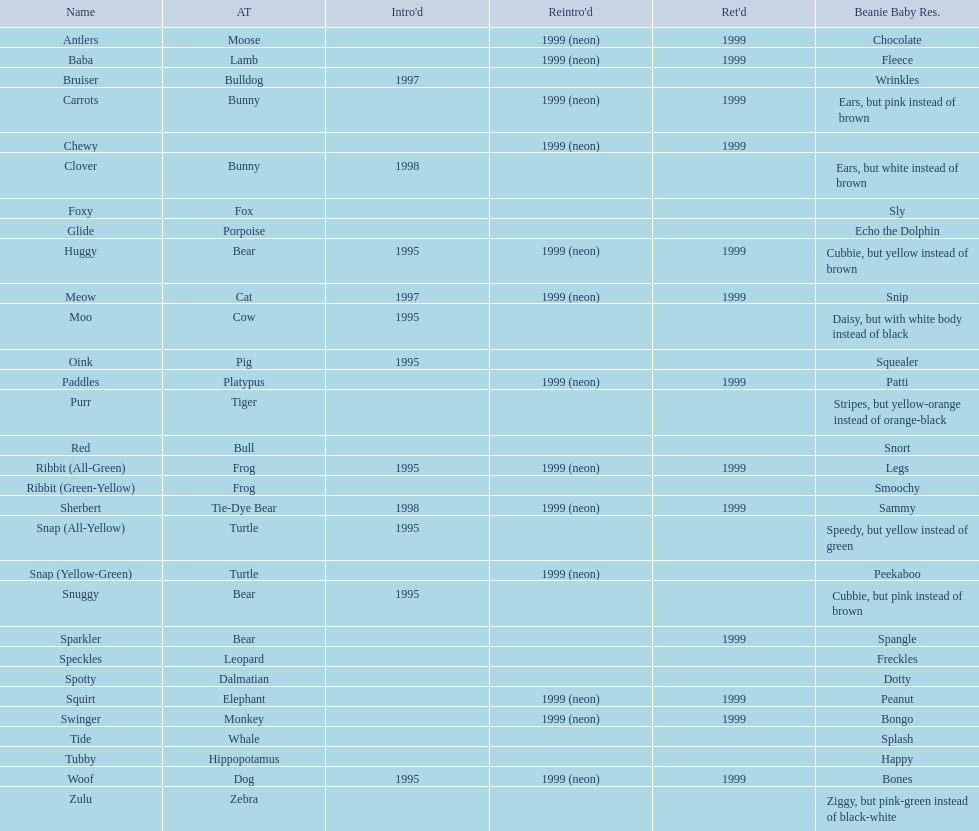What are all the pillow pals? Antlers, Baba, Bruiser, Carrots, Chewy, Clover, Foxy, Glide, Huggy, Meow, Moo, Oink, Paddles, Purr, Red, Ribbit (All-Green), Ribbit (Green-Yellow), Sherbert, Snap (All-Yellow), Snap (Yellow-Green), Snuggy, Sparkler, Speckles, Spotty, Squirt, Swinger, Tide, Tubby, Woof, Zulu. Which is the only without a listed animal type? Chewy. 